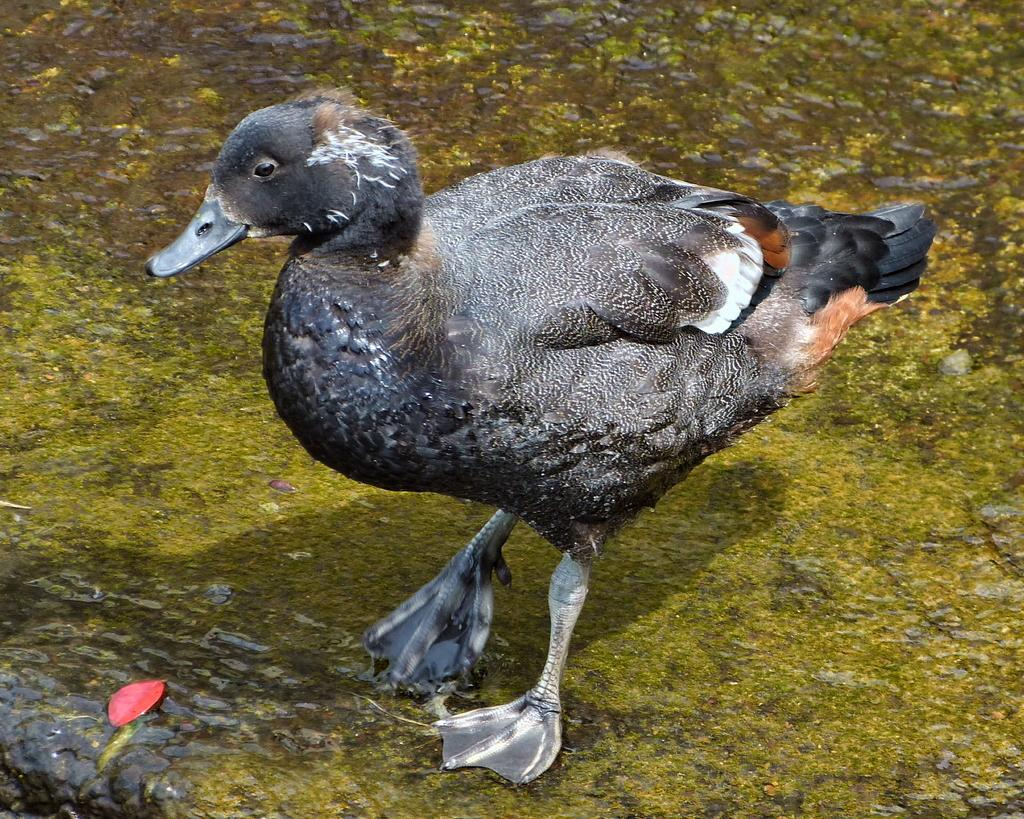What animal is the main subject of the image? There is a duck in the image. Where is the duck located in the image? The duck is in the center of the image. What type of environment is the duck in? The duck is on a grassland. How much money does the duck have in the image? There is no indication of money in the image, as it features a duck on a grassland. 